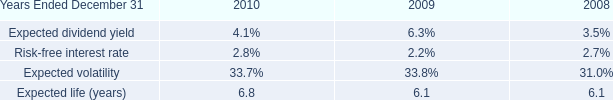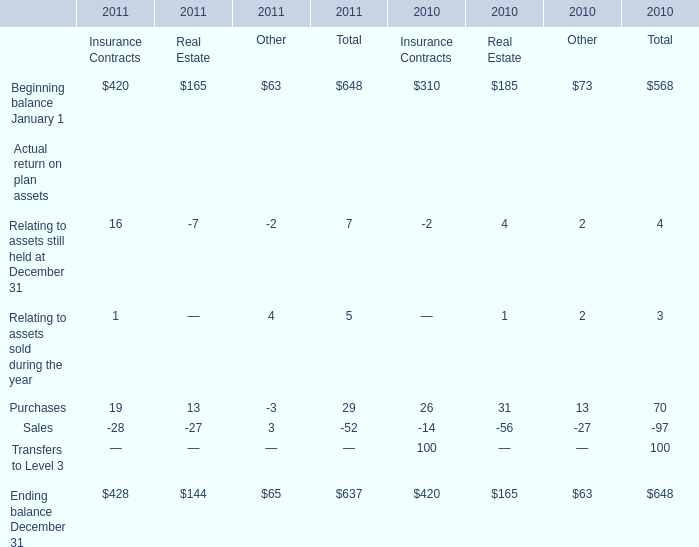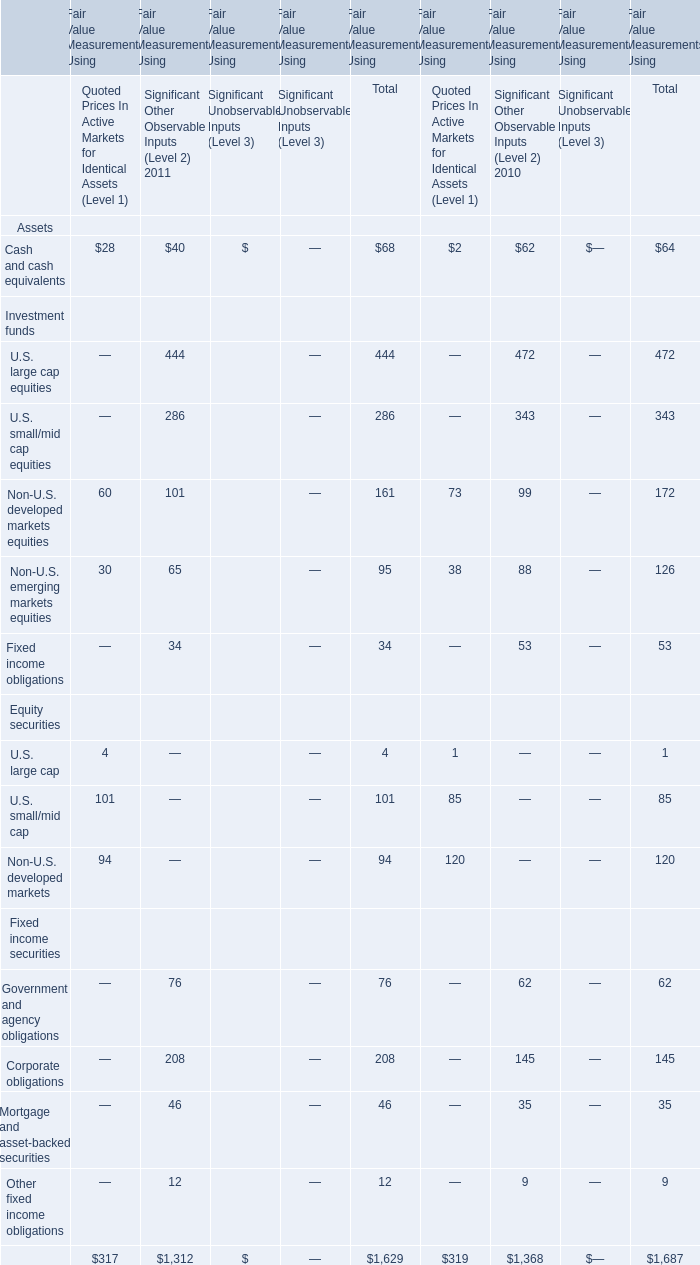What's the growth rate of the total amount of the corporate obligations for Fair Value Measurements Using in 2011? 
Computations: ((208 - 145) / 145)
Answer: 0.43448. 